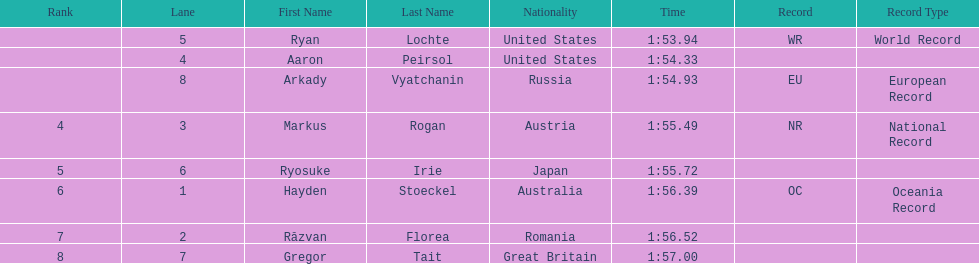How many names are listed? 8. 